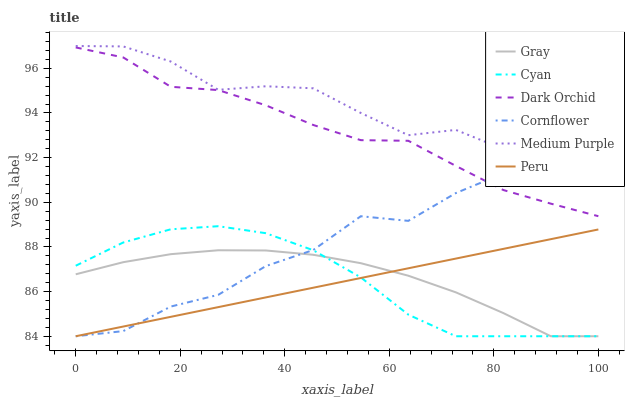Does Cornflower have the minimum area under the curve?
Answer yes or no. No. Does Cornflower have the maximum area under the curve?
Answer yes or no. No. Is Dark Orchid the smoothest?
Answer yes or no. No. Is Dark Orchid the roughest?
Answer yes or no. No. Does Dark Orchid have the lowest value?
Answer yes or no. No. Does Cornflower have the highest value?
Answer yes or no. No. Is Peru less than Dark Orchid?
Answer yes or no. Yes. Is Medium Purple greater than Gray?
Answer yes or no. Yes. Does Peru intersect Dark Orchid?
Answer yes or no. No. 